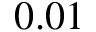Convert formula to latex. <formula><loc_0><loc_0><loc_500><loc_500>0 . 0 1</formula> 